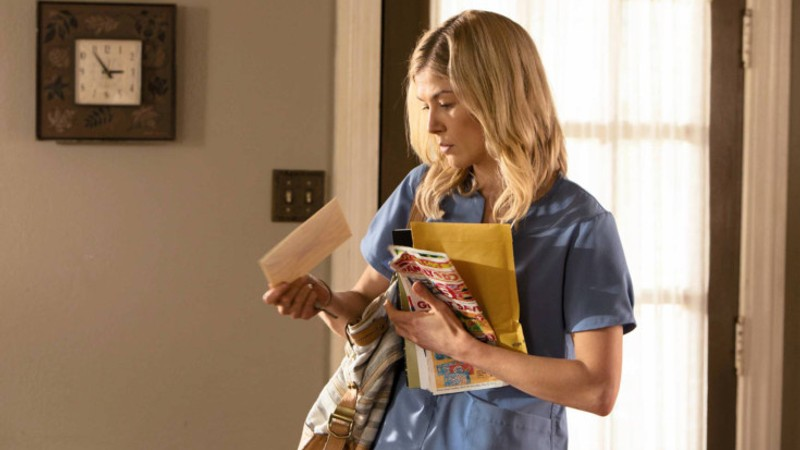Explain the visual content of the image in great detail. The image depicts a woman in a blue nurse's uniform holding a manila folder and a colorful tote bag. She is in an interior setting, possibly a home or small clinic, with a clock visible on the wall behind her and a window with horizontal blinds. Her expression suggests concentration or concern as she looks down at the folder, possibly reviewing documents or notes. The overall scene conveys a sense of professionalism mixed with personal engagement. 